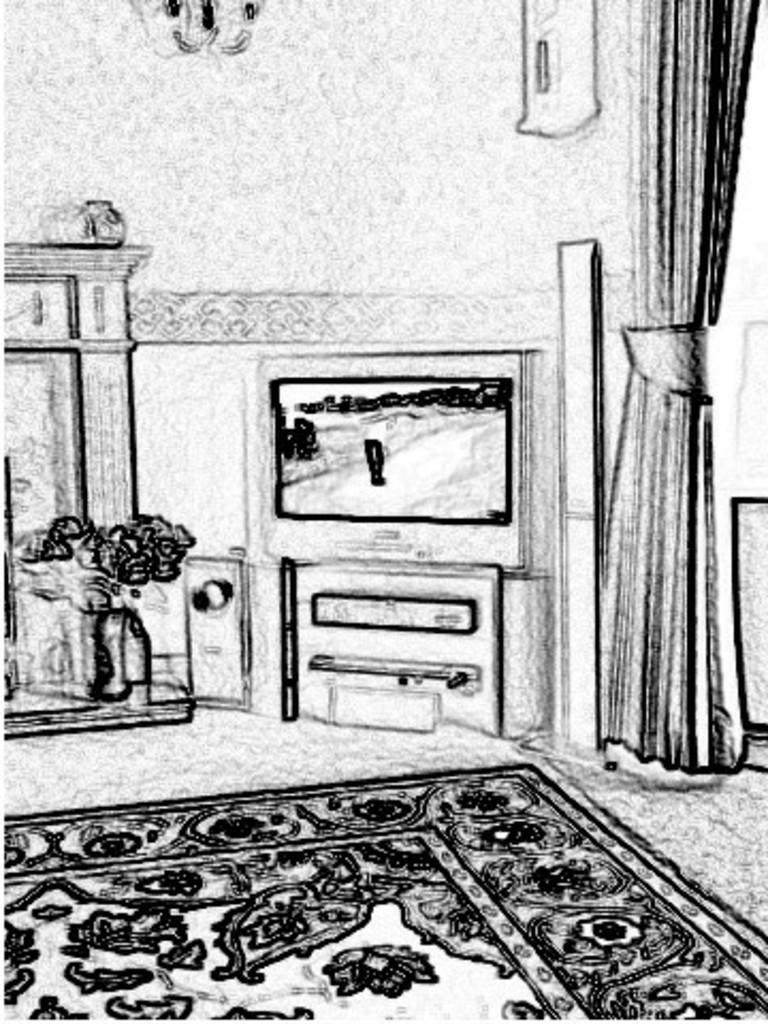What type of image is present in the picture? There is a graphical image in the picture. What type of flooring is visible in the picture? There is a carpet in the picture. What electronic device is present in the picture? There is a television in the picture. What type of window treatment is present in the picture? There is a curtain in the picture. What type of container for plants is present in the picture? There is a flower pot in the picture. Where is the kitty sitting on the tray in the picture? There is no kitty or tray present in the picture. What type of can is visible in the picture? There is no can present in the picture. 